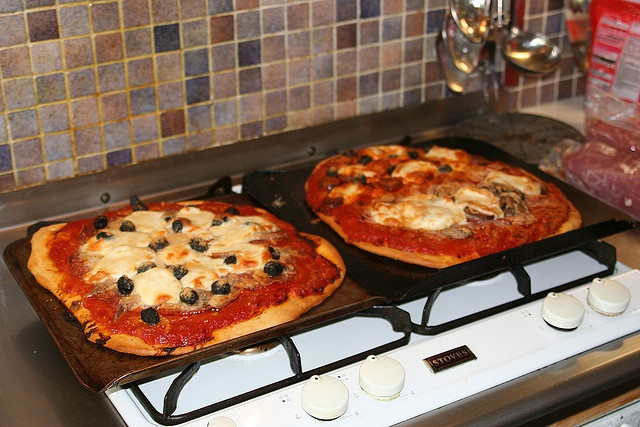Describe the objects in this image and their specific colors. I can see oven in gray, black, lightgray, maroon, and brown tones, pizza in gray, brown, and tan tones, pizza in gray, brown, maroon, and tan tones, spoon in gray, maroon, and black tones, and spoon in gray and maroon tones in this image. 